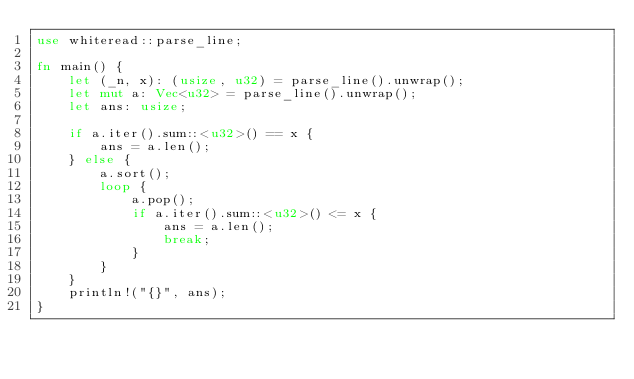Convert code to text. <code><loc_0><loc_0><loc_500><loc_500><_Rust_>use whiteread::parse_line;

fn main() {
    let (_n, x): (usize, u32) = parse_line().unwrap();
    let mut a: Vec<u32> = parse_line().unwrap();
    let ans: usize;

    if a.iter().sum::<u32>() == x {
        ans = a.len();
    } else {
        a.sort();
        loop {
            a.pop();
            if a.iter().sum::<u32>() <= x {
                ans = a.len();
                break;
            }
        }
    }
    println!("{}", ans);
}
</code> 